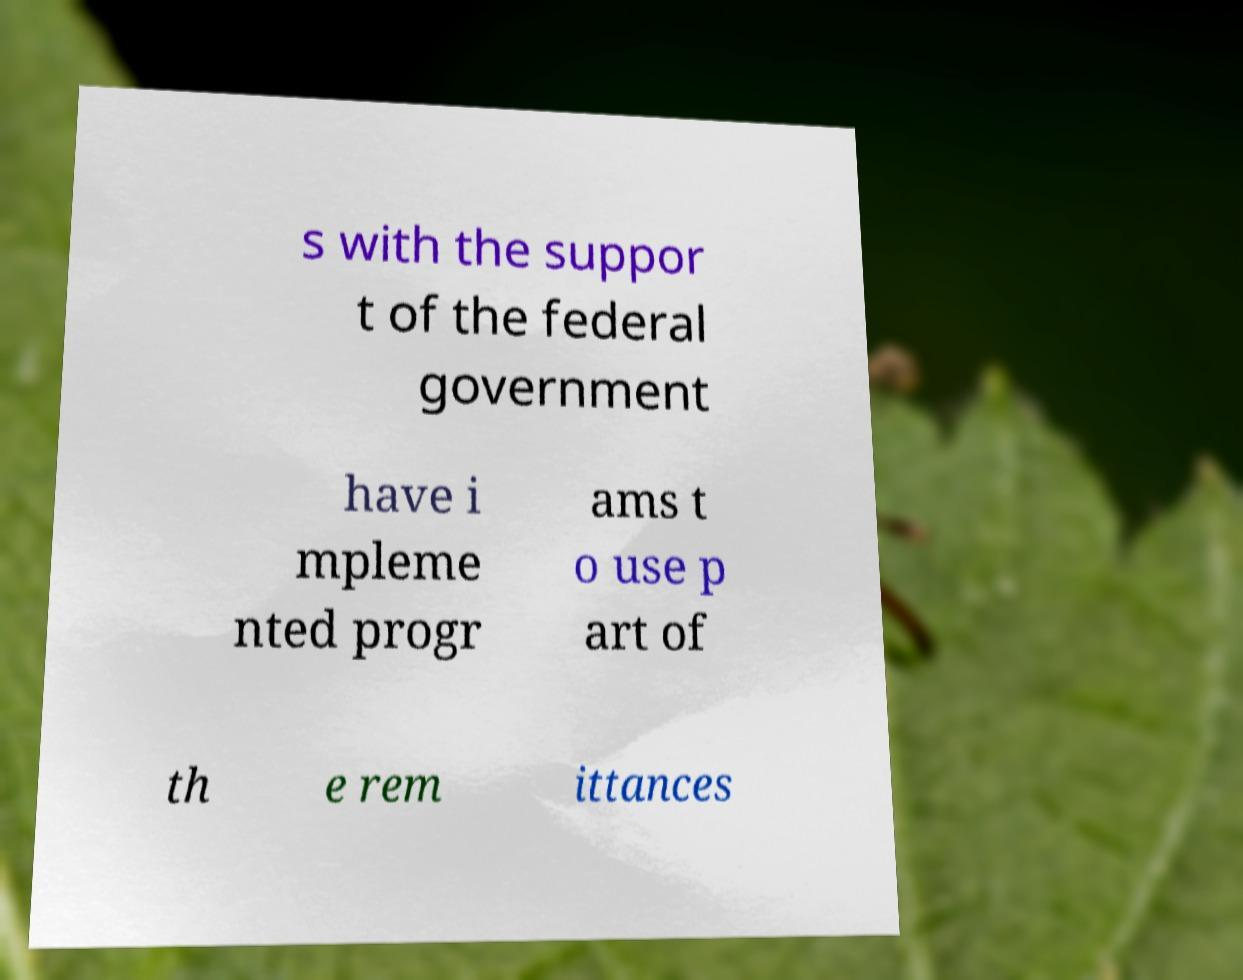Please identify and transcribe the text found in this image. s with the suppor t of the federal government have i mpleme nted progr ams t o use p art of th e rem ittances 